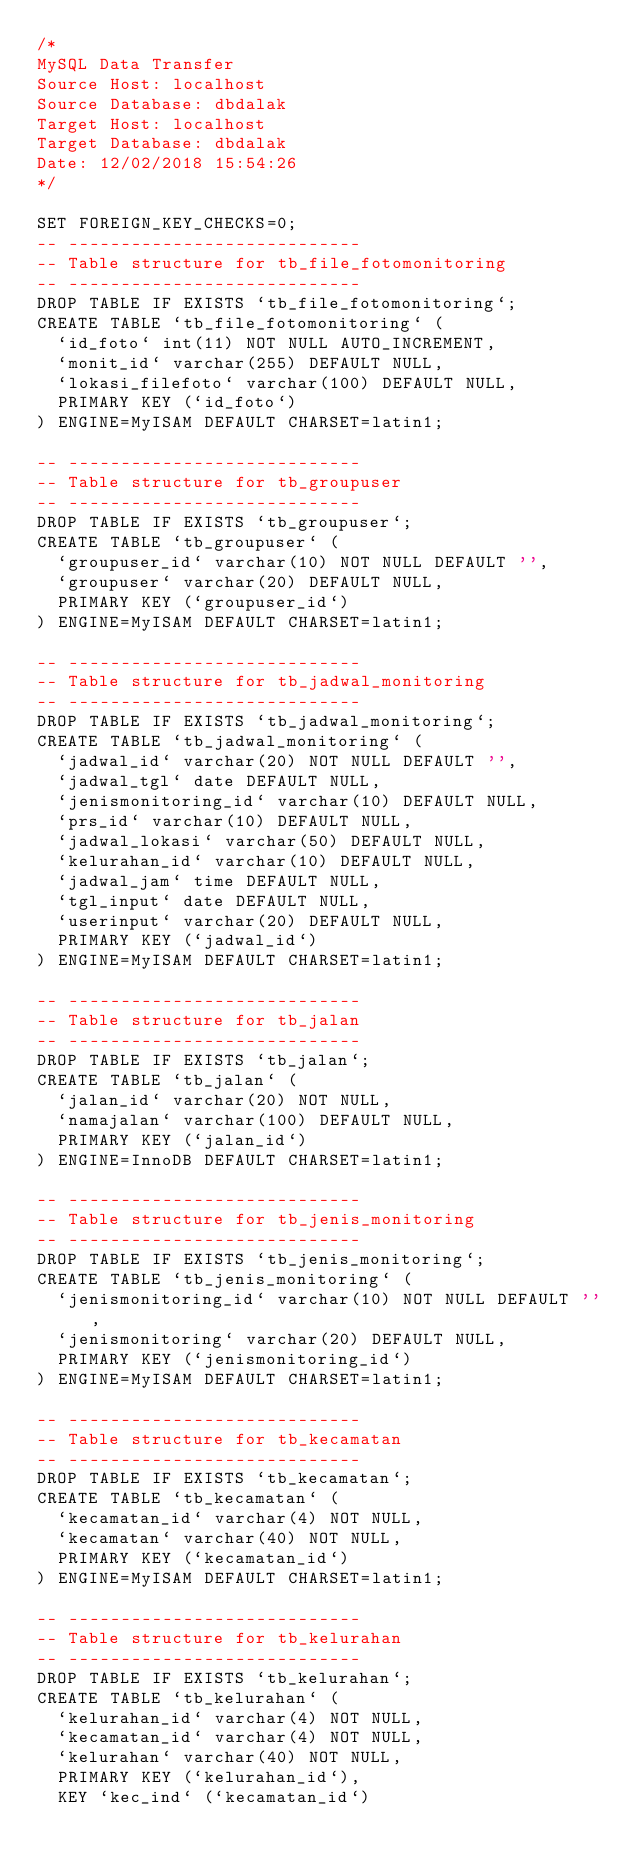<code> <loc_0><loc_0><loc_500><loc_500><_SQL_>/*
MySQL Data Transfer
Source Host: localhost
Source Database: dbdalak
Target Host: localhost
Target Database: dbdalak
Date: 12/02/2018 15:54:26
*/

SET FOREIGN_KEY_CHECKS=0;
-- ----------------------------
-- Table structure for tb_file_fotomonitoring
-- ----------------------------
DROP TABLE IF EXISTS `tb_file_fotomonitoring`;
CREATE TABLE `tb_file_fotomonitoring` (
  `id_foto` int(11) NOT NULL AUTO_INCREMENT,
  `monit_id` varchar(255) DEFAULT NULL,
  `lokasi_filefoto` varchar(100) DEFAULT NULL,
  PRIMARY KEY (`id_foto`)
) ENGINE=MyISAM DEFAULT CHARSET=latin1;

-- ----------------------------
-- Table structure for tb_groupuser
-- ----------------------------
DROP TABLE IF EXISTS `tb_groupuser`;
CREATE TABLE `tb_groupuser` (
  `groupuser_id` varchar(10) NOT NULL DEFAULT '',
  `groupuser` varchar(20) DEFAULT NULL,
  PRIMARY KEY (`groupuser_id`)
) ENGINE=MyISAM DEFAULT CHARSET=latin1;

-- ----------------------------
-- Table structure for tb_jadwal_monitoring
-- ----------------------------
DROP TABLE IF EXISTS `tb_jadwal_monitoring`;
CREATE TABLE `tb_jadwal_monitoring` (
  `jadwal_id` varchar(20) NOT NULL DEFAULT '',
  `jadwal_tgl` date DEFAULT NULL,
  `jenismonitoring_id` varchar(10) DEFAULT NULL,
  `prs_id` varchar(10) DEFAULT NULL,
  `jadwal_lokasi` varchar(50) DEFAULT NULL,
  `kelurahan_id` varchar(10) DEFAULT NULL,
  `jadwal_jam` time DEFAULT NULL,
  `tgl_input` date DEFAULT NULL,
  `userinput` varchar(20) DEFAULT NULL,
  PRIMARY KEY (`jadwal_id`)
) ENGINE=MyISAM DEFAULT CHARSET=latin1;

-- ----------------------------
-- Table structure for tb_jalan
-- ----------------------------
DROP TABLE IF EXISTS `tb_jalan`;
CREATE TABLE `tb_jalan` (
  `jalan_id` varchar(20) NOT NULL,
  `namajalan` varchar(100) DEFAULT NULL,
  PRIMARY KEY (`jalan_id`)
) ENGINE=InnoDB DEFAULT CHARSET=latin1;

-- ----------------------------
-- Table structure for tb_jenis_monitoring
-- ----------------------------
DROP TABLE IF EXISTS `tb_jenis_monitoring`;
CREATE TABLE `tb_jenis_monitoring` (
  `jenismonitoring_id` varchar(10) NOT NULL DEFAULT '',
  `jenismonitoring` varchar(20) DEFAULT NULL,
  PRIMARY KEY (`jenismonitoring_id`)
) ENGINE=MyISAM DEFAULT CHARSET=latin1;

-- ----------------------------
-- Table structure for tb_kecamatan
-- ----------------------------
DROP TABLE IF EXISTS `tb_kecamatan`;
CREATE TABLE `tb_kecamatan` (
  `kecamatan_id` varchar(4) NOT NULL,
  `kecamatan` varchar(40) NOT NULL,
  PRIMARY KEY (`kecamatan_id`)
) ENGINE=MyISAM DEFAULT CHARSET=latin1;

-- ----------------------------
-- Table structure for tb_kelurahan
-- ----------------------------
DROP TABLE IF EXISTS `tb_kelurahan`;
CREATE TABLE `tb_kelurahan` (
  `kelurahan_id` varchar(4) NOT NULL,
  `kecamatan_id` varchar(4) NOT NULL,
  `kelurahan` varchar(40) NOT NULL,
  PRIMARY KEY (`kelurahan_id`),
  KEY `kec_ind` (`kecamatan_id`)</code> 